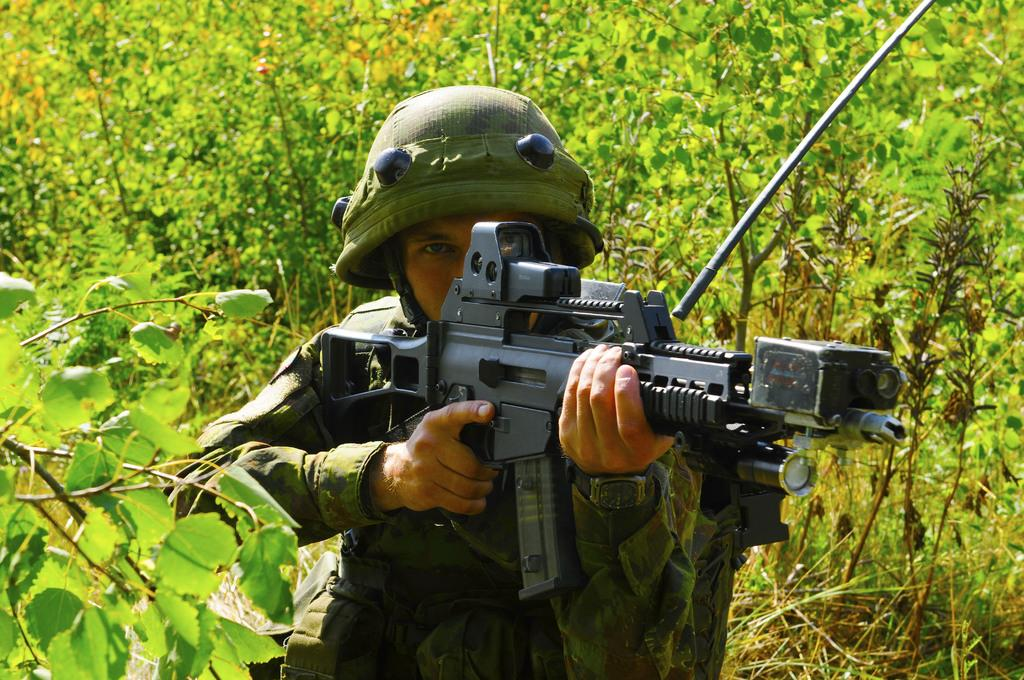What is the main subject of the image? The main subject of the image is an army personnel. What is the army personnel doing in the image? The army personnel is aiming at something with a gun in his hand. Can you describe the object beside the army personnel? There is an object beside the army personnel, but its description is not provided in the facts. What can be seen in the background of the image? There are trees around the army personnel. How does the army personnel sleep while holding the gun in the image? The army personnel is not sleeping in the image; he is aiming at something with a gun in his hand. What type of apparatus is used by the army personnel to communicate in the image? There is no apparatus visible in the image for communication purposes. 